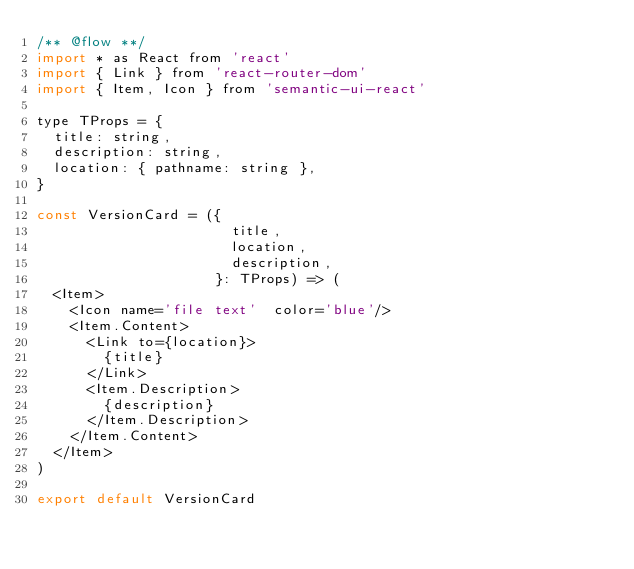<code> <loc_0><loc_0><loc_500><loc_500><_JavaScript_>/** @flow **/
import * as React from 'react'
import { Link } from 'react-router-dom'
import { Item, Icon } from 'semantic-ui-react'

type TProps = {
  title: string,
  description: string,
  location: { pathname: string },
}

const VersionCard = ({
                       title,
                       location,
                       description,
                     }: TProps) => (
  <Item>
    <Icon name='file text'  color='blue'/>
    <Item.Content>
      <Link to={location}>
        {title}
      </Link>
      <Item.Description>
        {description}
      </Item.Description>
    </Item.Content>
  </Item>
)

export default VersionCard</code> 